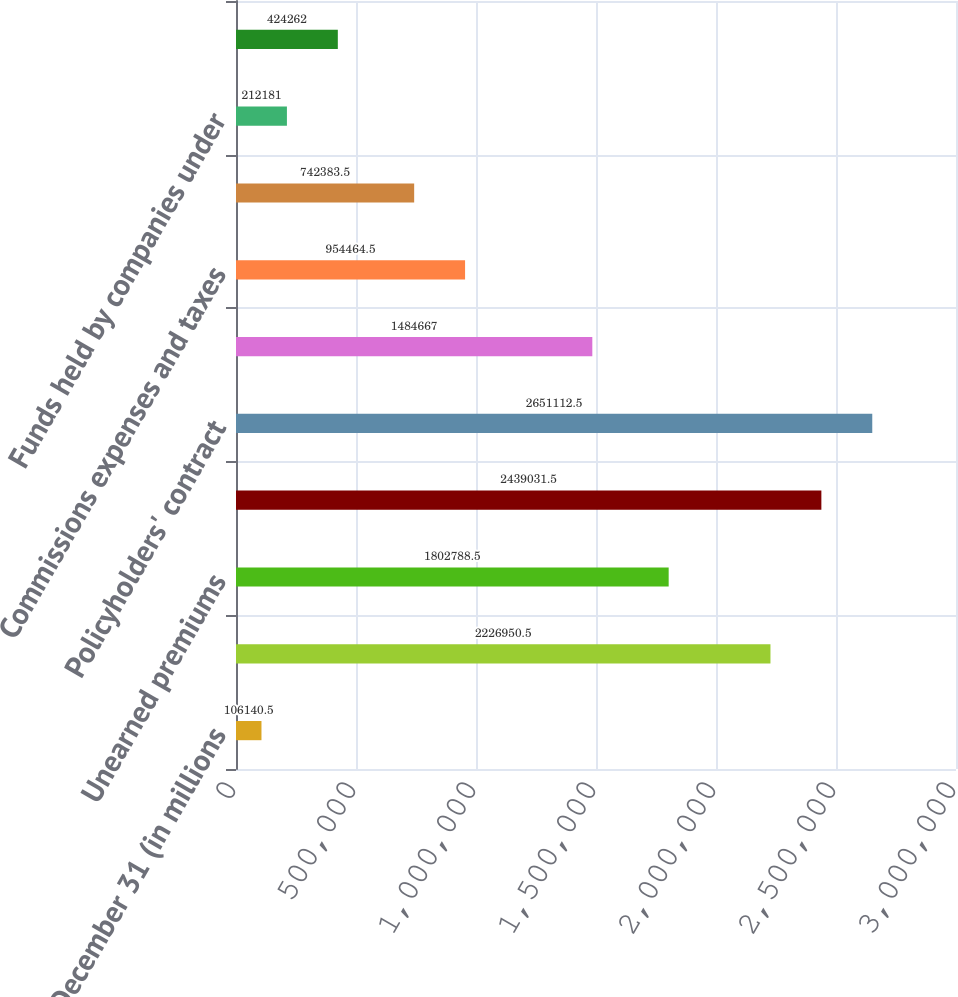Convert chart to OTSL. <chart><loc_0><loc_0><loc_500><loc_500><bar_chart><fcel>December 31 (in millions<fcel>Reserve for losses and loss<fcel>Unearned premiums<fcel>Future policy benefits for<fcel>Policyholders' contract<fcel>Other policyholders' funds<fcel>Commissions expenses and taxes<fcel>Insurance balances payable<fcel>Funds held by companies under<fcel>Income taxes payable<nl><fcel>106140<fcel>2.22695e+06<fcel>1.80279e+06<fcel>2.43903e+06<fcel>2.65111e+06<fcel>1.48467e+06<fcel>954464<fcel>742384<fcel>212181<fcel>424262<nl></chart> 